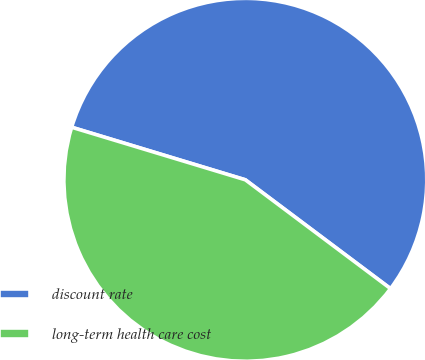<chart> <loc_0><loc_0><loc_500><loc_500><pie_chart><fcel>discount rate<fcel>long-term health care cost<nl><fcel>55.56%<fcel>44.44%<nl></chart> 